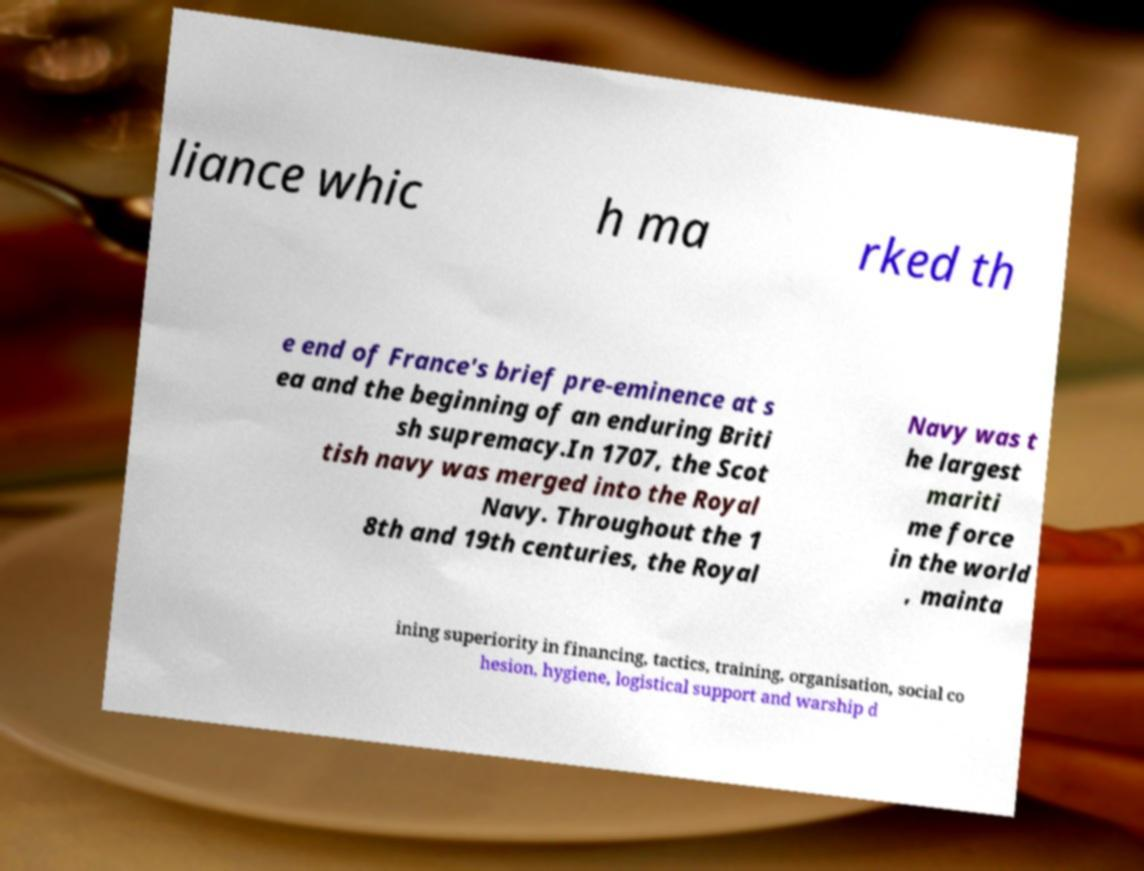There's text embedded in this image that I need extracted. Can you transcribe it verbatim? liance whic h ma rked th e end of France's brief pre-eminence at s ea and the beginning of an enduring Briti sh supremacy.In 1707, the Scot tish navy was merged into the Royal Navy. Throughout the 1 8th and 19th centuries, the Royal Navy was t he largest mariti me force in the world , mainta ining superiority in financing, tactics, training, organisation, social co hesion, hygiene, logistical support and warship d 